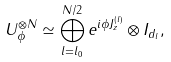<formula> <loc_0><loc_0><loc_500><loc_500>U _ { \phi } ^ { \otimes N } \simeq \bigoplus _ { l = l _ { 0 } } ^ { N / 2 } e ^ { i \phi J _ { z } ^ { ( l ) } } \otimes I _ { d _ { l } } ,</formula> 